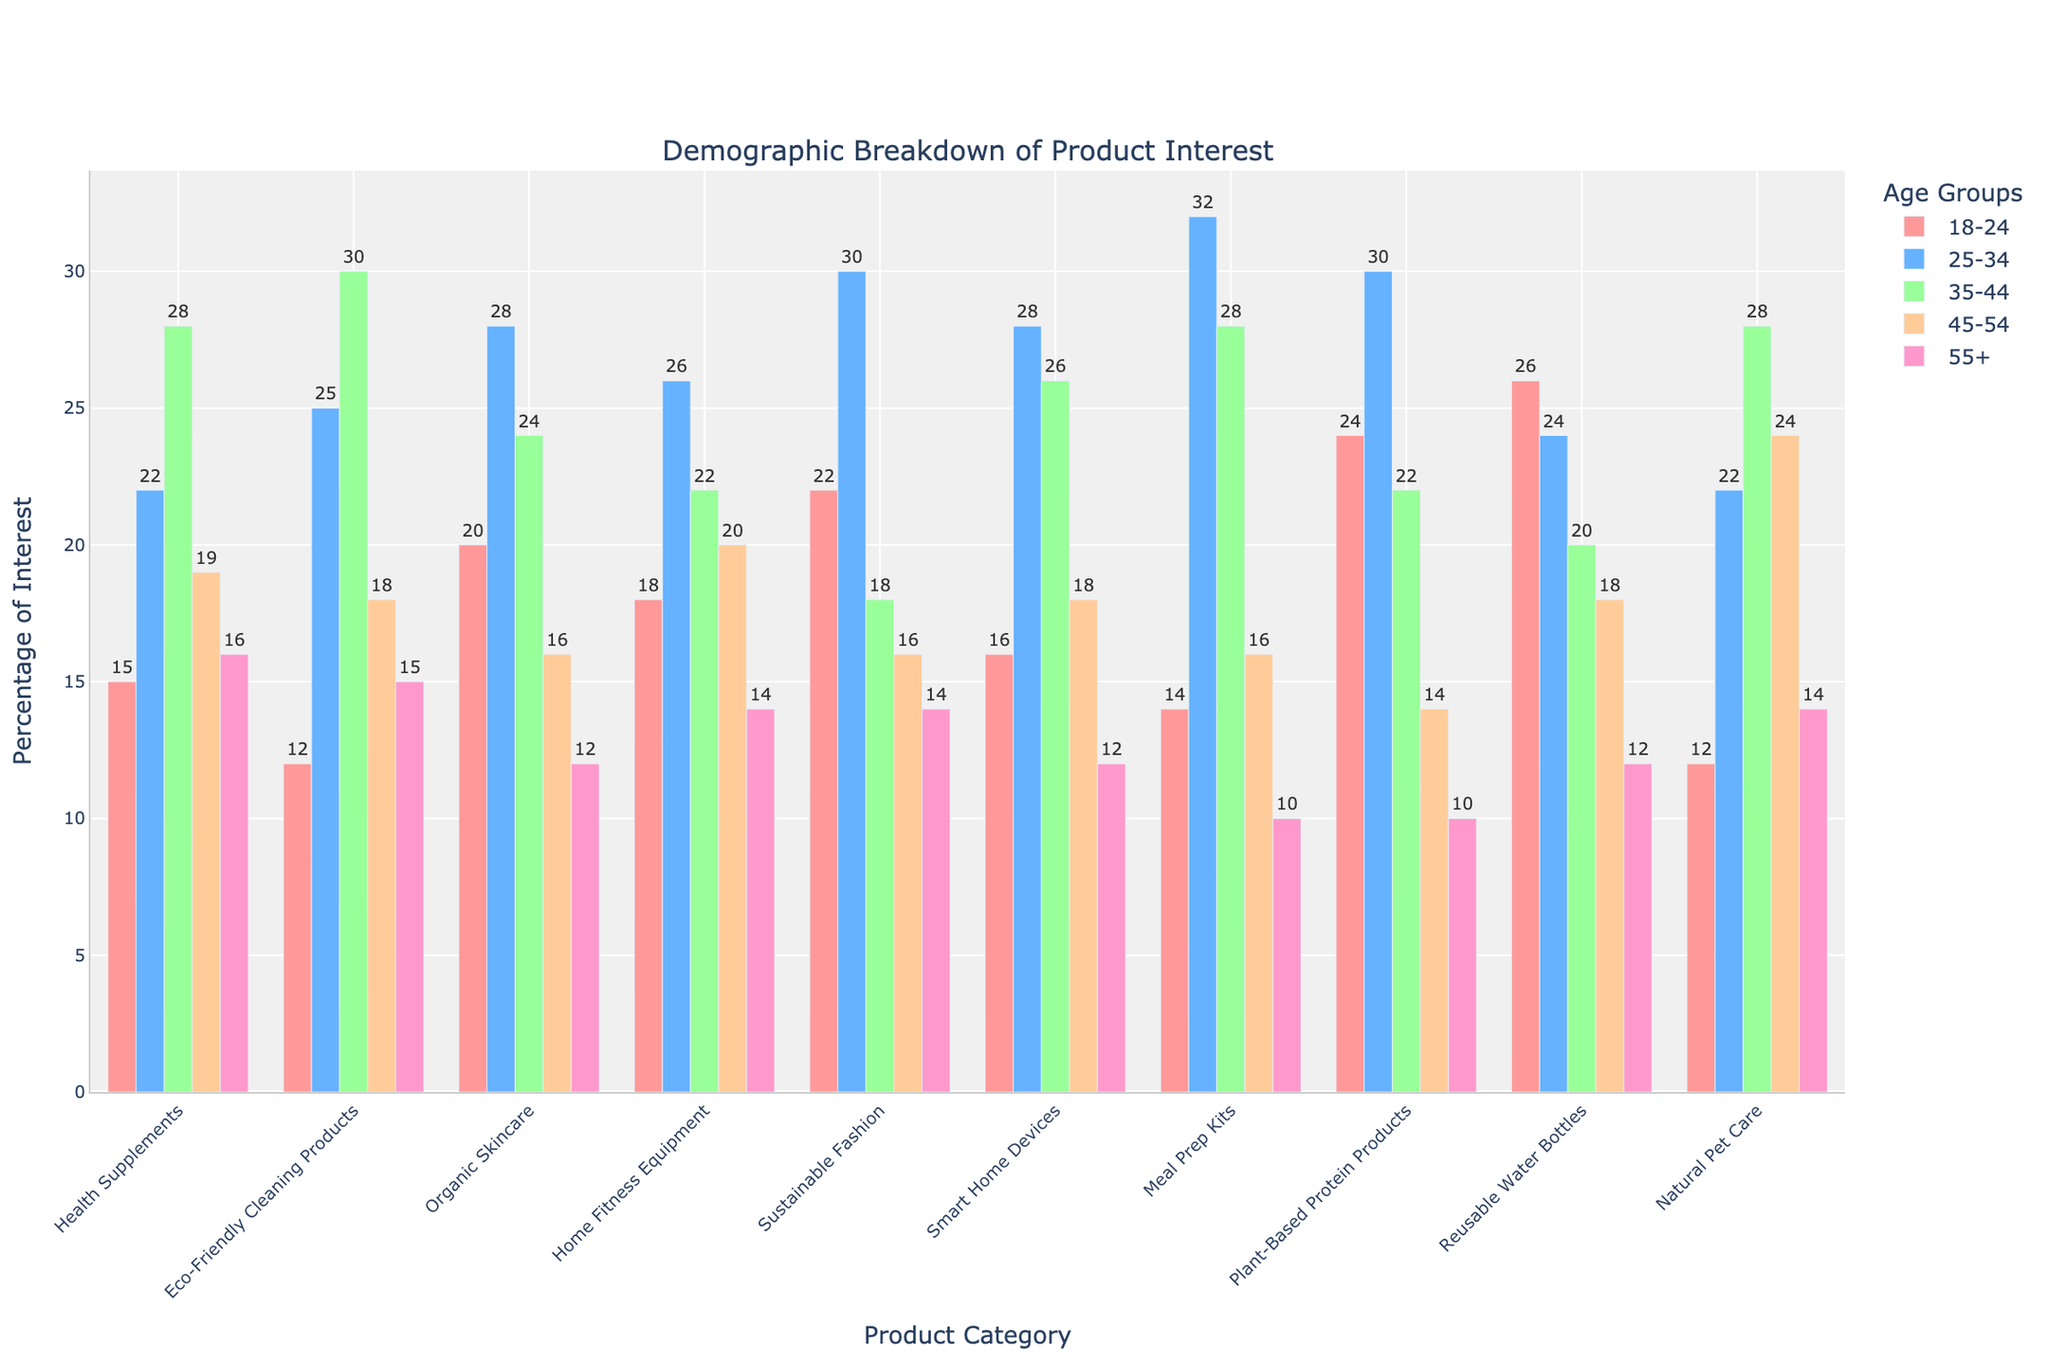Which age group shows the highest interest in Sustainable Fashion? The bar for the 25-34 age group in the Sustainable Fashion category is the tallest, indicating it has the highest interest.
Answer: 25-34 Among the age groups, which has the least interest in Meal Prep Kits? The bar for the 55+ age group in the Meal Prep Kits category is the smallest, indicating it has the least interest.
Answer: 55+ What's the total interest from the 18-24 and 25-34 age groups in Reusable Water Bottles? Sum the interest values for 18-24 and 25-34 age groups in Reusable Water Bottles: 26 + 24 = 50.
Answer: 50 Compare the 35-44 age group's interest in Natural Pet Care and Organic Skincare. Which is higher? The bar for 35-44 age group in Natural Pet Care is taller (28) compared to Organic Skincare (24), making it higher.
Answer: Natural Pet Care What's the average interest across all age groups for Home Fitness Equipment? Average by summing values and dividing by the number of age groups: (18 + 26 + 22 + 20 + 14) / 5 = 100 / 5 = 20.
Answer: 20 Does the 45-54 age group show more interest in Eco-Friendly Cleaning Products or Smart Home Devices? Compare the 45-54 age group's bars for both categories: Eco-Friendly Cleaning Products (18) versus Smart Home Devices (18). They are equal.
Answer: Equal Which age group has the second highest interest in Health Supplements? The second tallest bar in the Health Supplements category is for the 35-44 age group (28), after the 25-34 age group.
Answer: 35-44 For the Plant-Based Protein Products category, what is the difference in interest between the 18-24 and 55+ age groups? Subtract 55+ age group's interest from 18-24 age group's interest in Plant-Based Protein Products: 24 - 10 = 14.
Answer: 14 Which product category has the highest interest among the 25-34 age group? The tallest bar for the 25-34 age group is in the Meal Prep Kits category (32).
Answer: Meal Prep Kits What is the combined interest of 35-44 and 55+ age groups in Organic Skincare? Sum the interest values for 35-44 and 55+ age groups in Organic Skincare: 24 + 12 = 36.
Answer: 36 